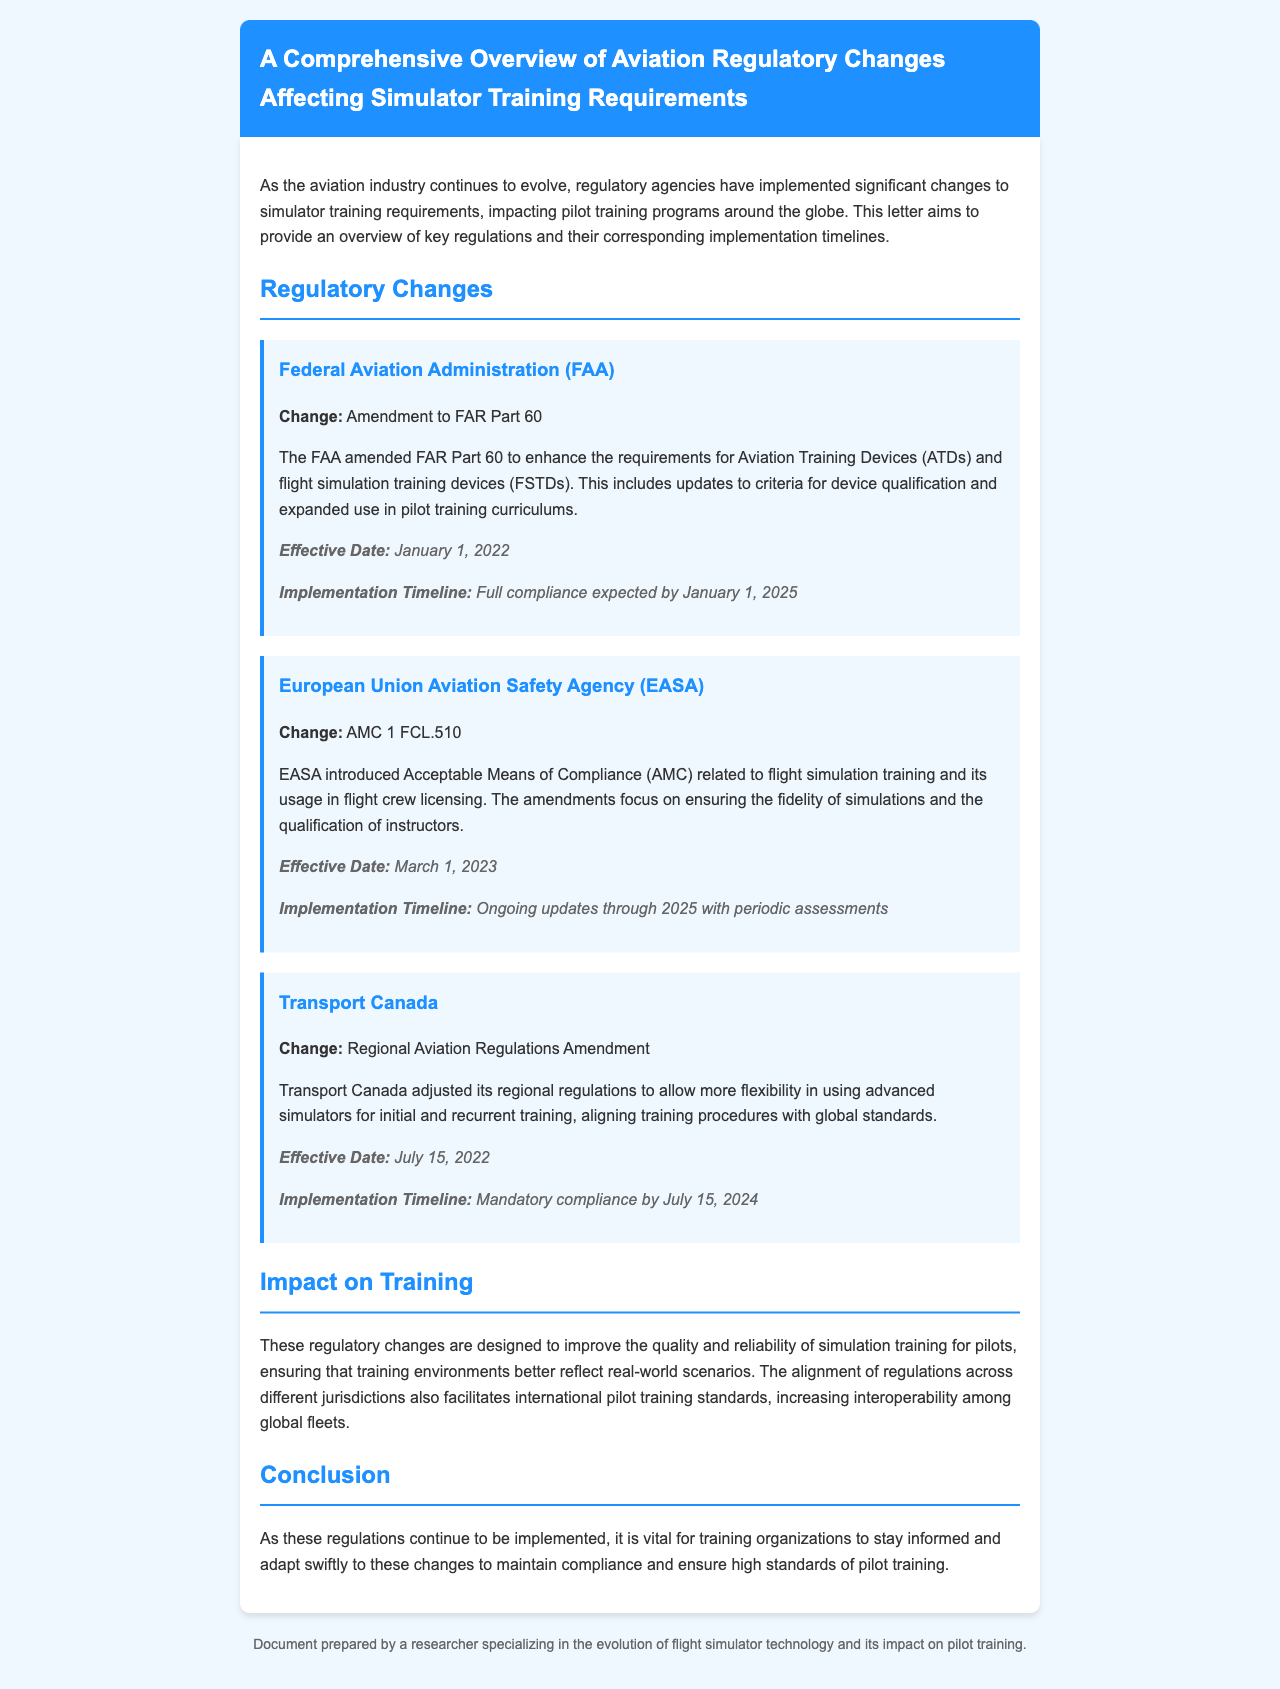What is the effective date for the FAA's amendment to FAR Part 60? The effective date for the FAA's amendment to FAR Part 60 is stated directly in the document, which is January 1, 2022.
Answer: January 1, 2022 What does AMC stand for in the context of EASA? AMC stands for Acceptable Means of Compliance in the context of EASA regulations.
Answer: Acceptable Means of Compliance What is the mandatory compliance deadline set by Transport Canada? The document specifies that mandatory compliance by Transport Canada is required by July 15, 2024.
Answer: July 15, 2024 Which agency introduced the AMC 1 FCL.510? The document identifies the European Union Aviation Safety Agency (EASA) as the agency that introduced AMC 1 FCL.510.
Answer: European Union Aviation Safety Agency What change was made by the FAA regarding Aviation Training Devices? The FAA's change involves an amendment to FAR Part 60, enhancing requirements for Aviation Training Devices (ATDs) and flight simulation training devices (FSTDs).
Answer: Amendment to FAR Part 60 What is the expected full compliance date for the FAA's regulation? According to the letter, full compliance for the FAA's regulation is expected by January 1, 2025.
Answer: January 1, 2025 How will these regulatory changes impact pilot training worldwide? The document explains that these changes are designed to improve quality and reliability of simulation training, facilitating international pilot training standards.
Answer: Improve quality and reliability What is the focus of the regulatory changes outlined in the document? The focus is on enhancing simulator training requirements for pilot training programs in the aviation industry.
Answer: Enhancing simulator training requirements Who prepared this document? The document indicates that it was prepared by a researcher specializing in flight simulator technology and its impact on pilot training.
Answer: A researcher specializing in flight simulator technology 